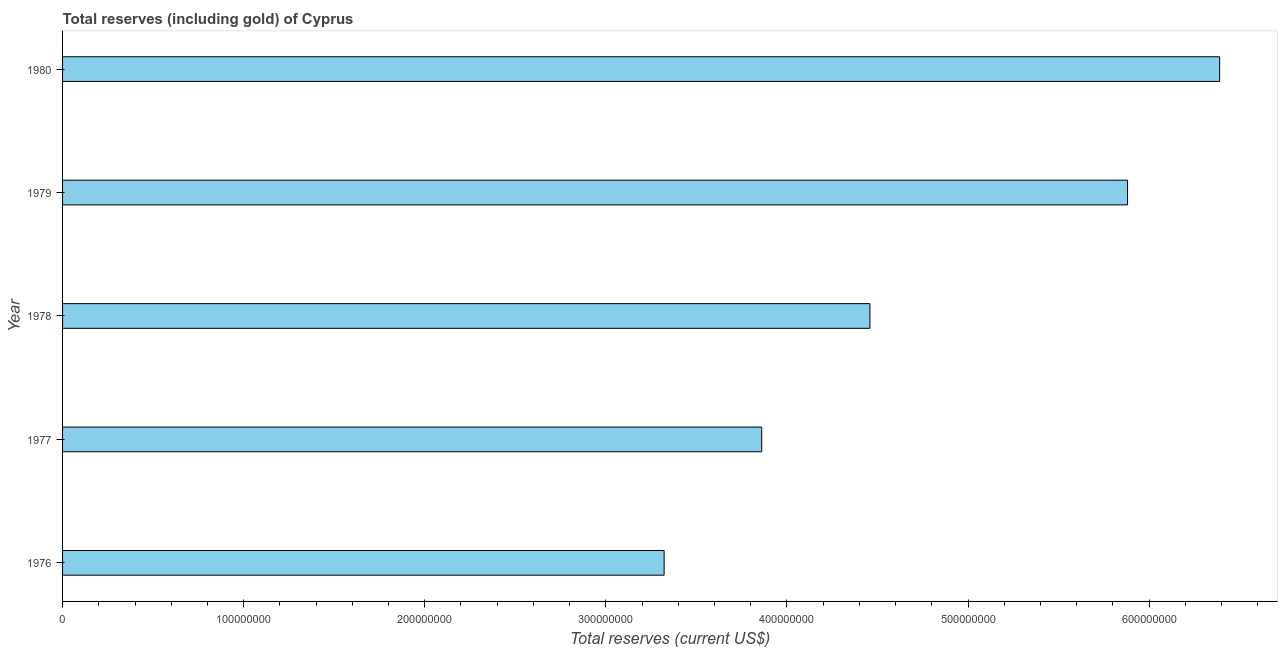Does the graph contain grids?
Keep it short and to the point. No. What is the title of the graph?
Your answer should be compact. Total reserves (including gold) of Cyprus. What is the label or title of the X-axis?
Your answer should be compact. Total reserves (current US$). What is the label or title of the Y-axis?
Provide a short and direct response. Year. What is the total reserves (including gold) in 1980?
Offer a very short reply. 6.39e+08. Across all years, what is the maximum total reserves (including gold)?
Provide a short and direct response. 6.39e+08. Across all years, what is the minimum total reserves (including gold)?
Give a very brief answer. 3.32e+08. In which year was the total reserves (including gold) minimum?
Offer a very short reply. 1976. What is the sum of the total reserves (including gold)?
Keep it short and to the point. 2.39e+09. What is the difference between the total reserves (including gold) in 1977 and 1980?
Your response must be concise. -2.53e+08. What is the average total reserves (including gold) per year?
Provide a succinct answer. 4.78e+08. What is the median total reserves (including gold)?
Provide a succinct answer. 4.46e+08. In how many years, is the total reserves (including gold) greater than 180000000 US$?
Keep it short and to the point. 5. What is the ratio of the total reserves (including gold) in 1977 to that in 1979?
Your answer should be compact. 0.66. What is the difference between the highest and the second highest total reserves (including gold)?
Your answer should be very brief. 5.08e+07. What is the difference between the highest and the lowest total reserves (including gold)?
Your answer should be very brief. 3.07e+08. How many bars are there?
Offer a terse response. 5. Are all the bars in the graph horizontal?
Your answer should be compact. Yes. What is the difference between two consecutive major ticks on the X-axis?
Ensure brevity in your answer.  1.00e+08. What is the Total reserves (current US$) of 1976?
Keep it short and to the point. 3.32e+08. What is the Total reserves (current US$) in 1977?
Provide a short and direct response. 3.86e+08. What is the Total reserves (current US$) of 1978?
Keep it short and to the point. 4.46e+08. What is the Total reserves (current US$) of 1979?
Offer a terse response. 5.88e+08. What is the Total reserves (current US$) in 1980?
Make the answer very short. 6.39e+08. What is the difference between the Total reserves (current US$) in 1976 and 1977?
Ensure brevity in your answer.  -5.39e+07. What is the difference between the Total reserves (current US$) in 1976 and 1978?
Your answer should be compact. -1.14e+08. What is the difference between the Total reserves (current US$) in 1976 and 1979?
Keep it short and to the point. -2.56e+08. What is the difference between the Total reserves (current US$) in 1976 and 1980?
Provide a succinct answer. -3.07e+08. What is the difference between the Total reserves (current US$) in 1977 and 1978?
Offer a terse response. -5.97e+07. What is the difference between the Total reserves (current US$) in 1977 and 1979?
Offer a very short reply. -2.02e+08. What is the difference between the Total reserves (current US$) in 1977 and 1980?
Make the answer very short. -2.53e+08. What is the difference between the Total reserves (current US$) in 1978 and 1979?
Ensure brevity in your answer.  -1.42e+08. What is the difference between the Total reserves (current US$) in 1978 and 1980?
Your response must be concise. -1.93e+08. What is the difference between the Total reserves (current US$) in 1979 and 1980?
Ensure brevity in your answer.  -5.08e+07. What is the ratio of the Total reserves (current US$) in 1976 to that in 1977?
Offer a very short reply. 0.86. What is the ratio of the Total reserves (current US$) in 1976 to that in 1978?
Provide a short and direct response. 0.74. What is the ratio of the Total reserves (current US$) in 1976 to that in 1979?
Keep it short and to the point. 0.56. What is the ratio of the Total reserves (current US$) in 1976 to that in 1980?
Offer a terse response. 0.52. What is the ratio of the Total reserves (current US$) in 1977 to that in 1978?
Ensure brevity in your answer.  0.87. What is the ratio of the Total reserves (current US$) in 1977 to that in 1979?
Offer a terse response. 0.66. What is the ratio of the Total reserves (current US$) in 1977 to that in 1980?
Provide a short and direct response. 0.6. What is the ratio of the Total reserves (current US$) in 1978 to that in 1979?
Keep it short and to the point. 0.76. What is the ratio of the Total reserves (current US$) in 1978 to that in 1980?
Your response must be concise. 0.7. 